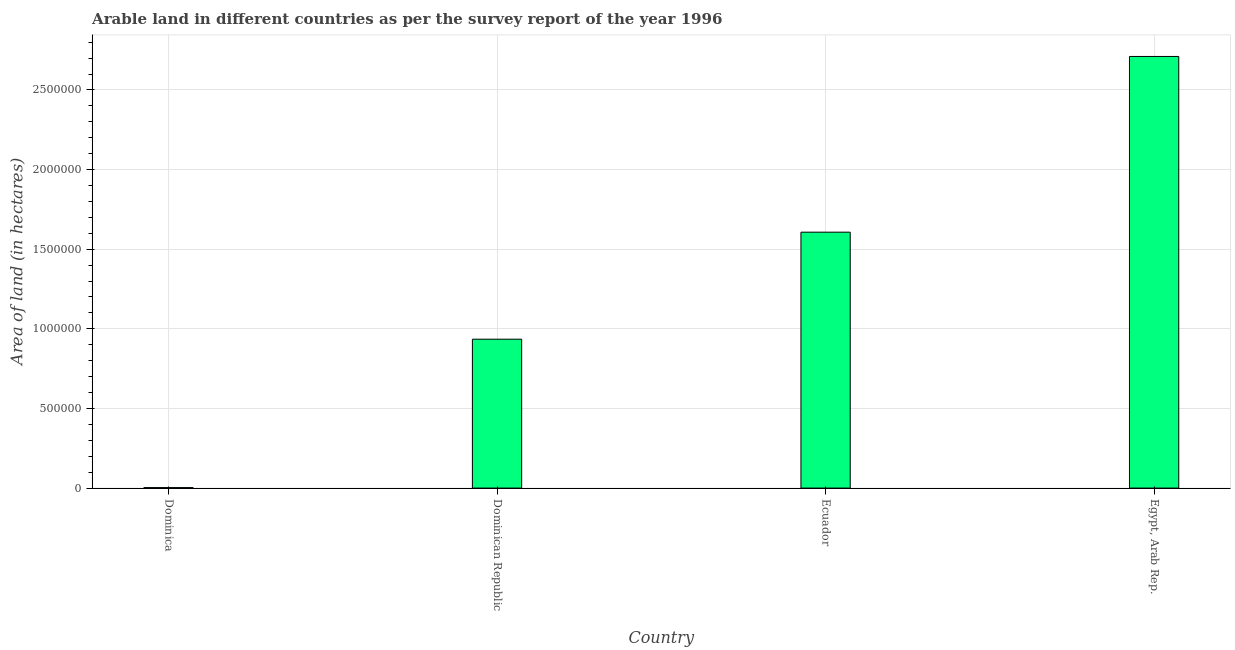What is the title of the graph?
Your response must be concise. Arable land in different countries as per the survey report of the year 1996. What is the label or title of the X-axis?
Offer a very short reply. Country. What is the label or title of the Y-axis?
Your response must be concise. Area of land (in hectares). What is the area of land in Ecuador?
Your answer should be very brief. 1.61e+06. Across all countries, what is the maximum area of land?
Give a very brief answer. 2.71e+06. Across all countries, what is the minimum area of land?
Offer a very short reply. 3000. In which country was the area of land maximum?
Provide a succinct answer. Egypt, Arab Rep. In which country was the area of land minimum?
Offer a very short reply. Dominica. What is the sum of the area of land?
Offer a terse response. 5.26e+06. What is the difference between the area of land in Dominica and Dominican Republic?
Your response must be concise. -9.32e+05. What is the average area of land per country?
Offer a very short reply. 1.31e+06. What is the median area of land?
Make the answer very short. 1.27e+06. What is the difference between the highest and the second highest area of land?
Your answer should be very brief. 1.10e+06. What is the difference between the highest and the lowest area of land?
Keep it short and to the point. 2.71e+06. How many bars are there?
Your answer should be compact. 4. What is the Area of land (in hectares) in Dominica?
Your answer should be very brief. 3000. What is the Area of land (in hectares) in Dominican Republic?
Give a very brief answer. 9.35e+05. What is the Area of land (in hectares) of Ecuador?
Keep it short and to the point. 1.61e+06. What is the Area of land (in hectares) of Egypt, Arab Rep.?
Ensure brevity in your answer.  2.71e+06. What is the difference between the Area of land (in hectares) in Dominica and Dominican Republic?
Give a very brief answer. -9.32e+05. What is the difference between the Area of land (in hectares) in Dominica and Ecuador?
Ensure brevity in your answer.  -1.60e+06. What is the difference between the Area of land (in hectares) in Dominica and Egypt, Arab Rep.?
Ensure brevity in your answer.  -2.71e+06. What is the difference between the Area of land (in hectares) in Dominican Republic and Ecuador?
Your answer should be compact. -6.72e+05. What is the difference between the Area of land (in hectares) in Dominican Republic and Egypt, Arab Rep.?
Your answer should be very brief. -1.78e+06. What is the difference between the Area of land (in hectares) in Ecuador and Egypt, Arab Rep.?
Keep it short and to the point. -1.10e+06. What is the ratio of the Area of land (in hectares) in Dominica to that in Dominican Republic?
Ensure brevity in your answer.  0. What is the ratio of the Area of land (in hectares) in Dominica to that in Ecuador?
Provide a succinct answer. 0. What is the ratio of the Area of land (in hectares) in Dominican Republic to that in Ecuador?
Ensure brevity in your answer.  0.58. What is the ratio of the Area of land (in hectares) in Dominican Republic to that in Egypt, Arab Rep.?
Provide a short and direct response. 0.34. What is the ratio of the Area of land (in hectares) in Ecuador to that in Egypt, Arab Rep.?
Offer a very short reply. 0.59. 